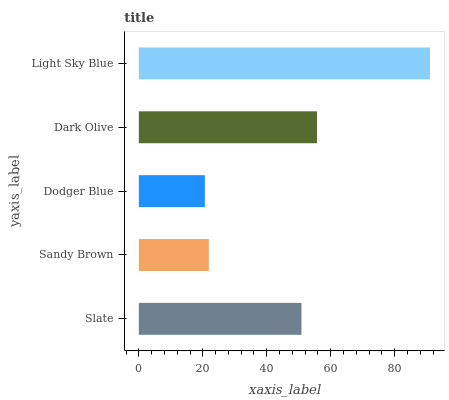Is Dodger Blue the minimum?
Answer yes or no. Yes. Is Light Sky Blue the maximum?
Answer yes or no. Yes. Is Sandy Brown the minimum?
Answer yes or no. No. Is Sandy Brown the maximum?
Answer yes or no. No. Is Slate greater than Sandy Brown?
Answer yes or no. Yes. Is Sandy Brown less than Slate?
Answer yes or no. Yes. Is Sandy Brown greater than Slate?
Answer yes or no. No. Is Slate less than Sandy Brown?
Answer yes or no. No. Is Slate the high median?
Answer yes or no. Yes. Is Slate the low median?
Answer yes or no. Yes. Is Sandy Brown the high median?
Answer yes or no. No. Is Dark Olive the low median?
Answer yes or no. No. 